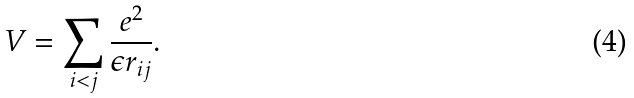Convert formula to latex. <formula><loc_0><loc_0><loc_500><loc_500>V = \sum _ { i < j } \frac { e ^ { 2 } } { \epsilon r _ { i j } } .</formula> 